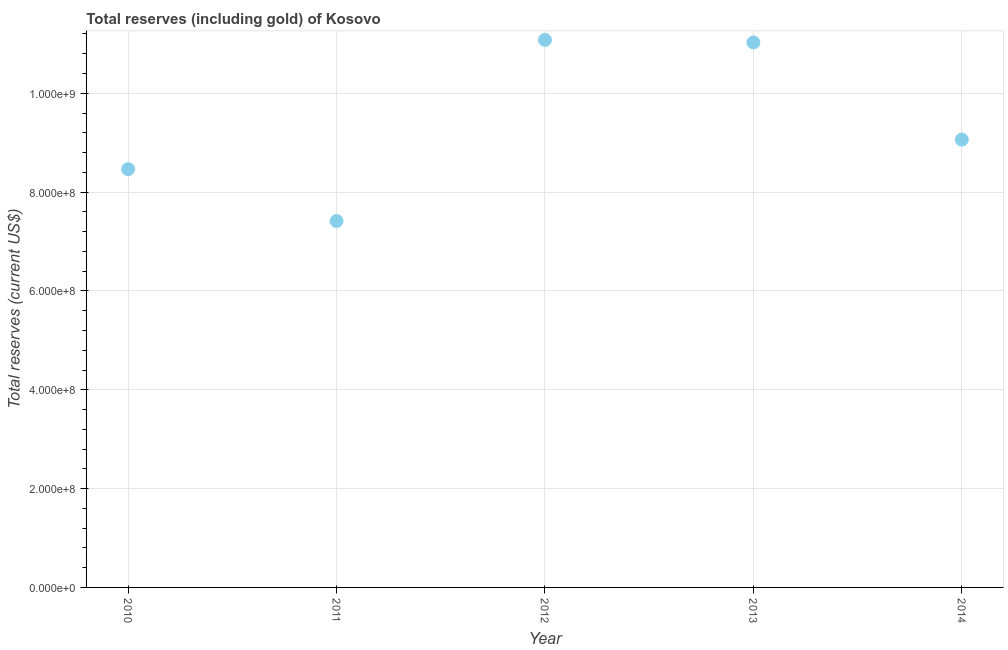What is the total reserves (including gold) in 2010?
Make the answer very short. 8.46e+08. Across all years, what is the maximum total reserves (including gold)?
Your answer should be very brief. 1.11e+09. Across all years, what is the minimum total reserves (including gold)?
Provide a short and direct response. 7.42e+08. In which year was the total reserves (including gold) minimum?
Offer a very short reply. 2011. What is the sum of the total reserves (including gold)?
Make the answer very short. 4.71e+09. What is the difference between the total reserves (including gold) in 2010 and 2011?
Give a very brief answer. 1.05e+08. What is the average total reserves (including gold) per year?
Keep it short and to the point. 9.41e+08. What is the median total reserves (including gold)?
Your response must be concise. 9.06e+08. What is the ratio of the total reserves (including gold) in 2011 to that in 2014?
Your response must be concise. 0.82. What is the difference between the highest and the second highest total reserves (including gold)?
Ensure brevity in your answer.  5.18e+06. Is the sum of the total reserves (including gold) in 2011 and 2013 greater than the maximum total reserves (including gold) across all years?
Ensure brevity in your answer.  Yes. What is the difference between the highest and the lowest total reserves (including gold)?
Make the answer very short. 3.67e+08. How many dotlines are there?
Your answer should be compact. 1. How many years are there in the graph?
Provide a short and direct response. 5. What is the difference between two consecutive major ticks on the Y-axis?
Your response must be concise. 2.00e+08. Does the graph contain grids?
Make the answer very short. Yes. What is the title of the graph?
Give a very brief answer. Total reserves (including gold) of Kosovo. What is the label or title of the Y-axis?
Offer a very short reply. Total reserves (current US$). What is the Total reserves (current US$) in 2010?
Provide a succinct answer. 8.46e+08. What is the Total reserves (current US$) in 2011?
Provide a short and direct response. 7.42e+08. What is the Total reserves (current US$) in 2012?
Ensure brevity in your answer.  1.11e+09. What is the Total reserves (current US$) in 2013?
Give a very brief answer. 1.10e+09. What is the Total reserves (current US$) in 2014?
Your response must be concise. 9.06e+08. What is the difference between the Total reserves (current US$) in 2010 and 2011?
Give a very brief answer. 1.05e+08. What is the difference between the Total reserves (current US$) in 2010 and 2012?
Keep it short and to the point. -2.62e+08. What is the difference between the Total reserves (current US$) in 2010 and 2013?
Offer a terse response. -2.57e+08. What is the difference between the Total reserves (current US$) in 2010 and 2014?
Make the answer very short. -5.99e+07. What is the difference between the Total reserves (current US$) in 2011 and 2012?
Provide a succinct answer. -3.67e+08. What is the difference between the Total reserves (current US$) in 2011 and 2013?
Keep it short and to the point. -3.61e+08. What is the difference between the Total reserves (current US$) in 2011 and 2014?
Your answer should be very brief. -1.65e+08. What is the difference between the Total reserves (current US$) in 2012 and 2013?
Offer a terse response. 5.18e+06. What is the difference between the Total reserves (current US$) in 2012 and 2014?
Provide a succinct answer. 2.02e+08. What is the difference between the Total reserves (current US$) in 2013 and 2014?
Offer a very short reply. 1.97e+08. What is the ratio of the Total reserves (current US$) in 2010 to that in 2011?
Provide a succinct answer. 1.14. What is the ratio of the Total reserves (current US$) in 2010 to that in 2012?
Provide a short and direct response. 0.76. What is the ratio of the Total reserves (current US$) in 2010 to that in 2013?
Your response must be concise. 0.77. What is the ratio of the Total reserves (current US$) in 2010 to that in 2014?
Give a very brief answer. 0.93. What is the ratio of the Total reserves (current US$) in 2011 to that in 2012?
Your response must be concise. 0.67. What is the ratio of the Total reserves (current US$) in 2011 to that in 2013?
Give a very brief answer. 0.67. What is the ratio of the Total reserves (current US$) in 2011 to that in 2014?
Your answer should be very brief. 0.82. What is the ratio of the Total reserves (current US$) in 2012 to that in 2013?
Provide a succinct answer. 1. What is the ratio of the Total reserves (current US$) in 2012 to that in 2014?
Keep it short and to the point. 1.22. What is the ratio of the Total reserves (current US$) in 2013 to that in 2014?
Your response must be concise. 1.22. 